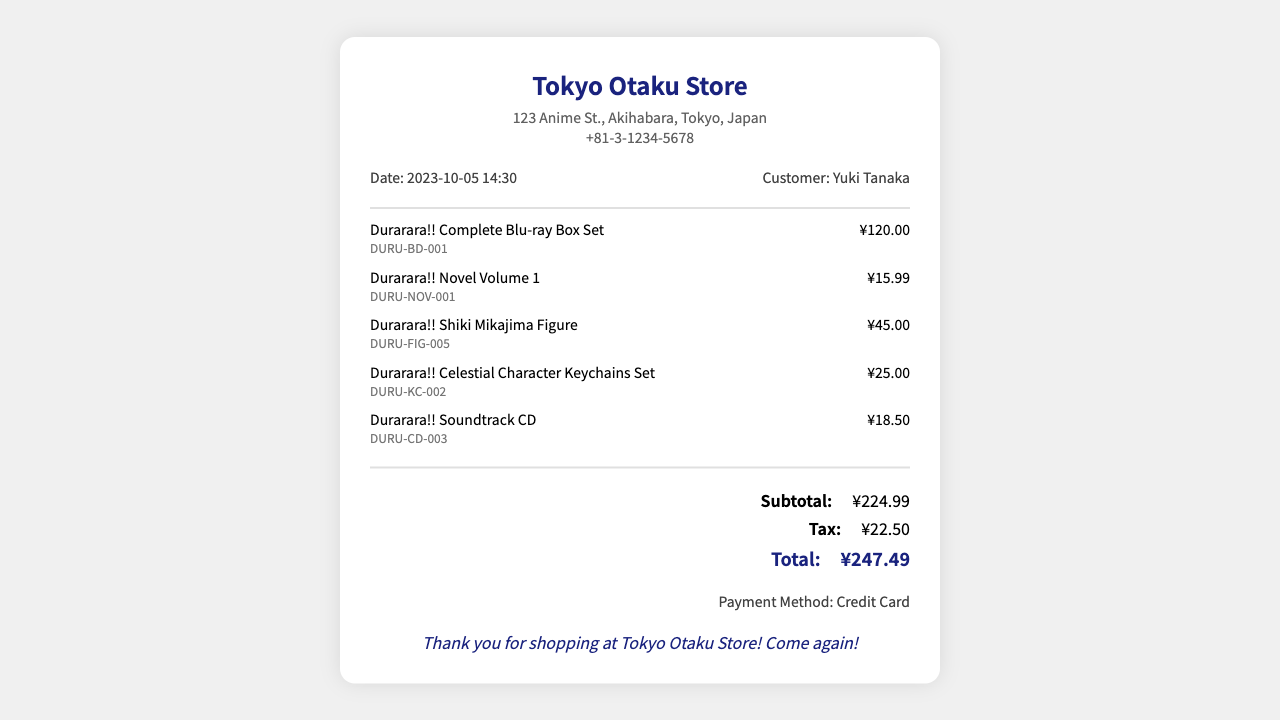What is the store name? The store name is prominently displayed at the top of the receipt.
Answer: Tokyo Otaku Store What is the date of the transaction? The date of the transaction is listed in the transaction information section of the receipt.
Answer: 2023-10-05 Who is the customer? The customer's name is indicated in the transaction information section.
Answer: Yuki Tanaka What is the payment method used? The payment method is mentioned at the bottom of the receipt.
Answer: Credit Card What is the price of the Durarara!! Complete Blu-ray Box Set? The price is indicated next to the item's description on the receipt.
Answer: ¥120.00 What is the total amount before tax? The subtotal is provided in the totals section before any taxes are added.
Answer: ¥224.99 How much was collected as tax? The tax amount is explicitly stated in the totals section of the receipt.
Answer: ¥22.50 What is the total cost after tax? The total cost is listed at the end of the totals section.
Answer: ¥247.49 How many items were purchased in total? The number of items can be inferred from the individual item listings on the receipt.
Answer: 5 